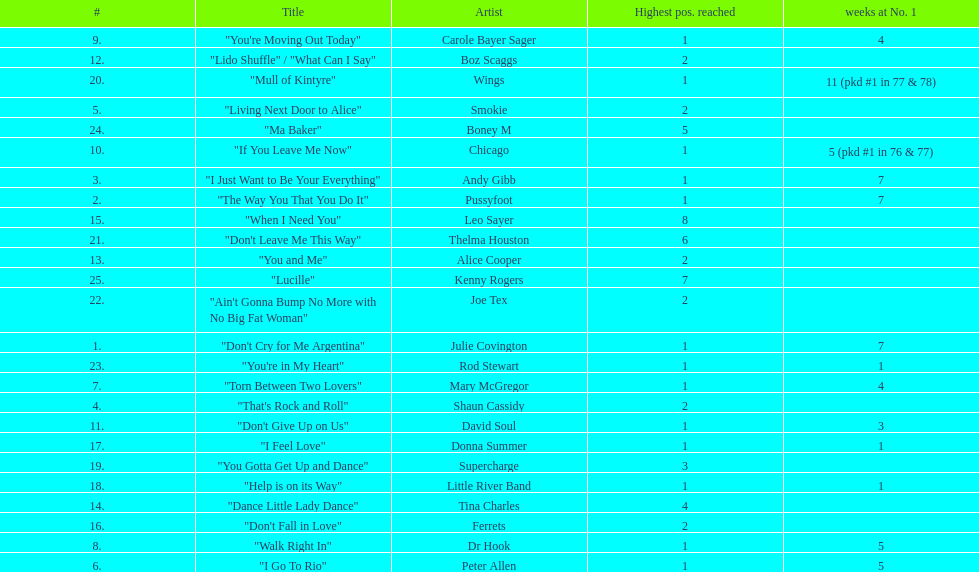How many weeks did julie covington's "don't cry for me argentina" spend at the top of australia's singles chart? 7. 